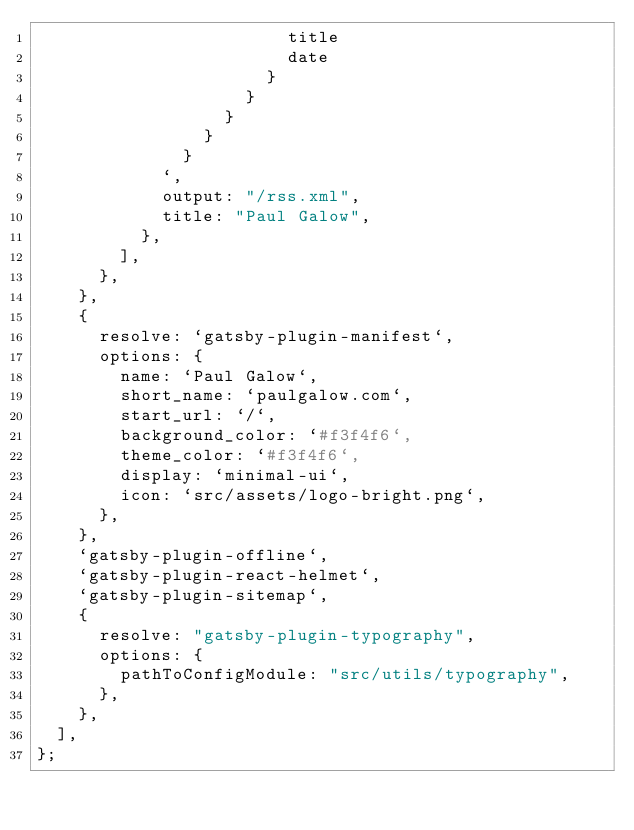Convert code to text. <code><loc_0><loc_0><loc_500><loc_500><_JavaScript_>                        title
                        date
                      }
                    }
                  }
                }
              }
            `,
            output: "/rss.xml",
            title: "Paul Galow",
          },
        ],
      },
    },
    {
      resolve: `gatsby-plugin-manifest`,
      options: {
        name: `Paul Galow`,
        short_name: `paulgalow.com`,
        start_url: `/`,
        background_color: `#f3f4f6`,
        theme_color: `#f3f4f6`,
        display: `minimal-ui`,
        icon: `src/assets/logo-bright.png`,
      },
    },
    `gatsby-plugin-offline`,
    `gatsby-plugin-react-helmet`,
    `gatsby-plugin-sitemap`,
    {
      resolve: "gatsby-plugin-typography",
      options: {
        pathToConfigModule: "src/utils/typography",
      },
    },
  ],
};
</code> 